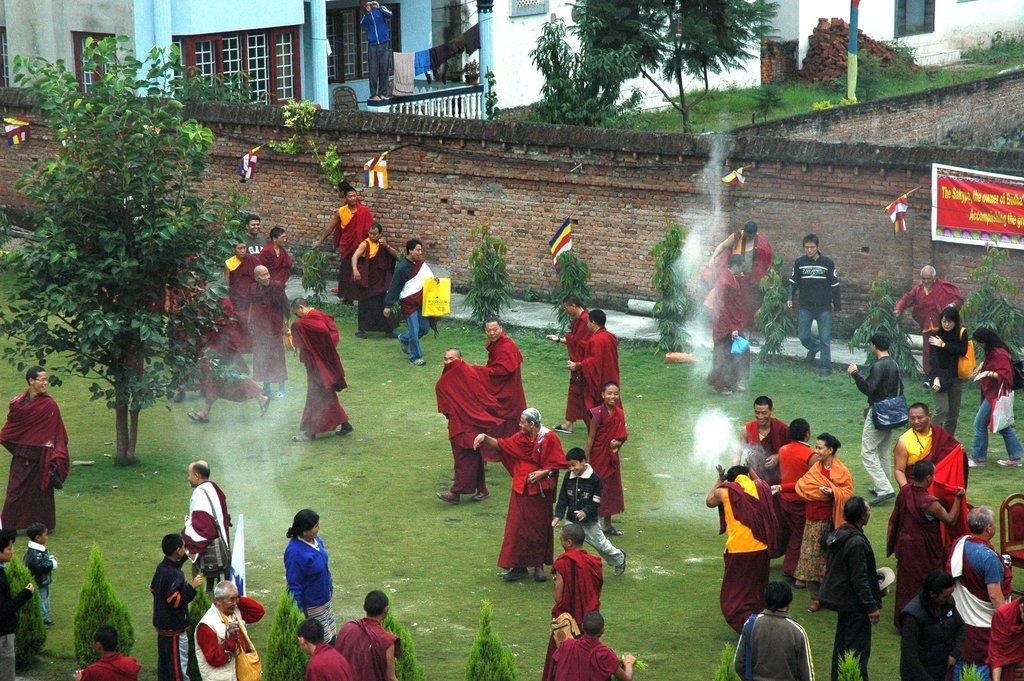What is happening on the ground in the image? There are people on the ground in the image. Can you describe the clothing of some of the people? Some of the people are wearing red color clothes. What can be seen in the background of the image? There is a wall, buildings, trees, and grass visible in the image. Are there any additional decorations or items in the image? Yes, flags and a banner on the wall are present in the image. Can you tell me how many cacti are visible in the image? There are no cacti present in the image. What type of branch is being used to surprise the people in the image? There is no branch or surprise element present in the image. 